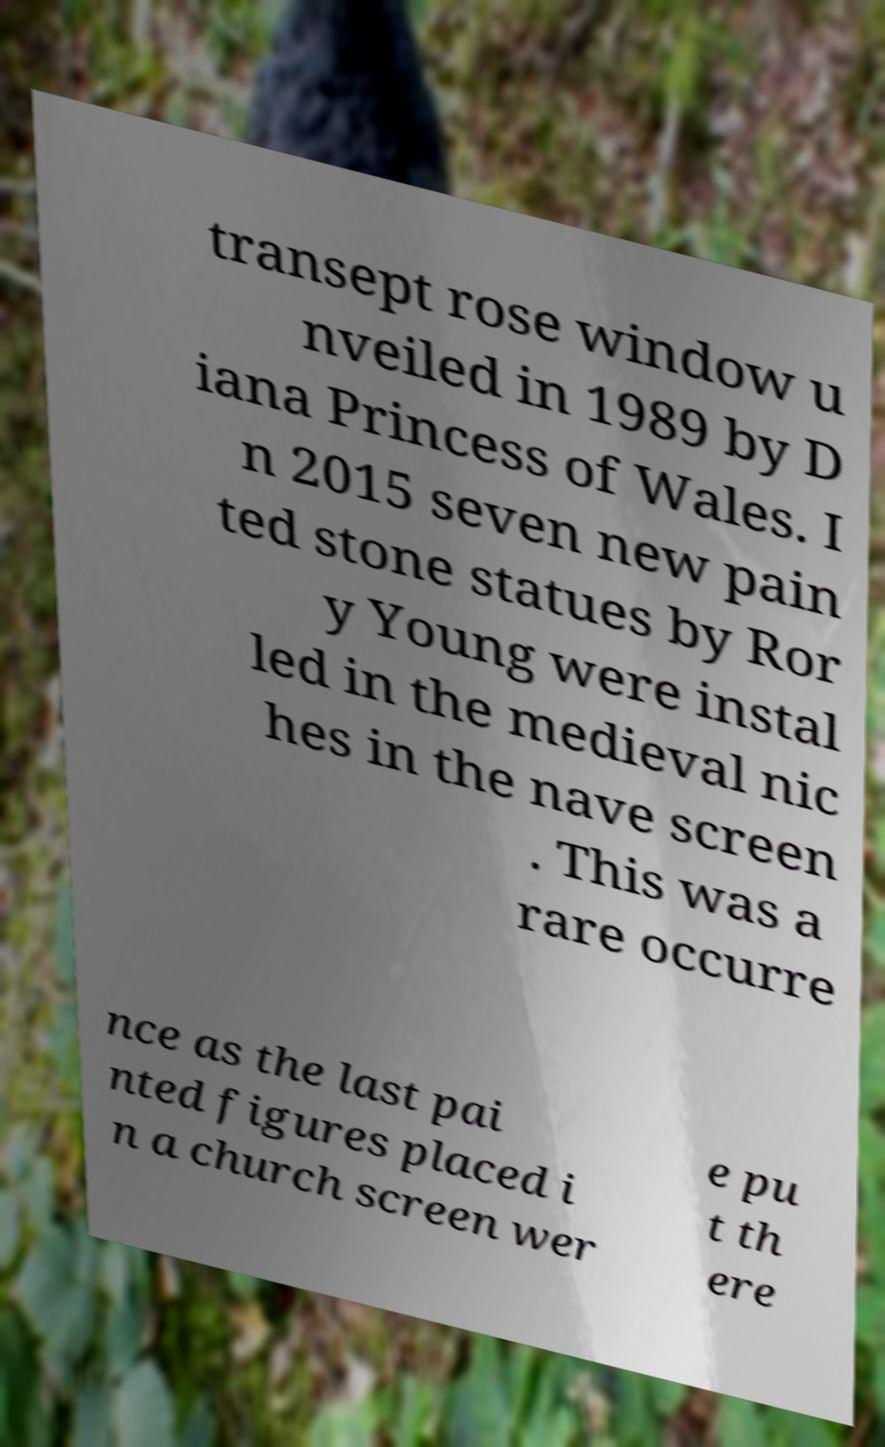Can you accurately transcribe the text from the provided image for me? transept rose window u nveiled in 1989 by D iana Princess of Wales. I n 2015 seven new pain ted stone statues by Ror y Young were instal led in the medieval nic hes in the nave screen . This was a rare occurre nce as the last pai nted figures placed i n a church screen wer e pu t th ere 